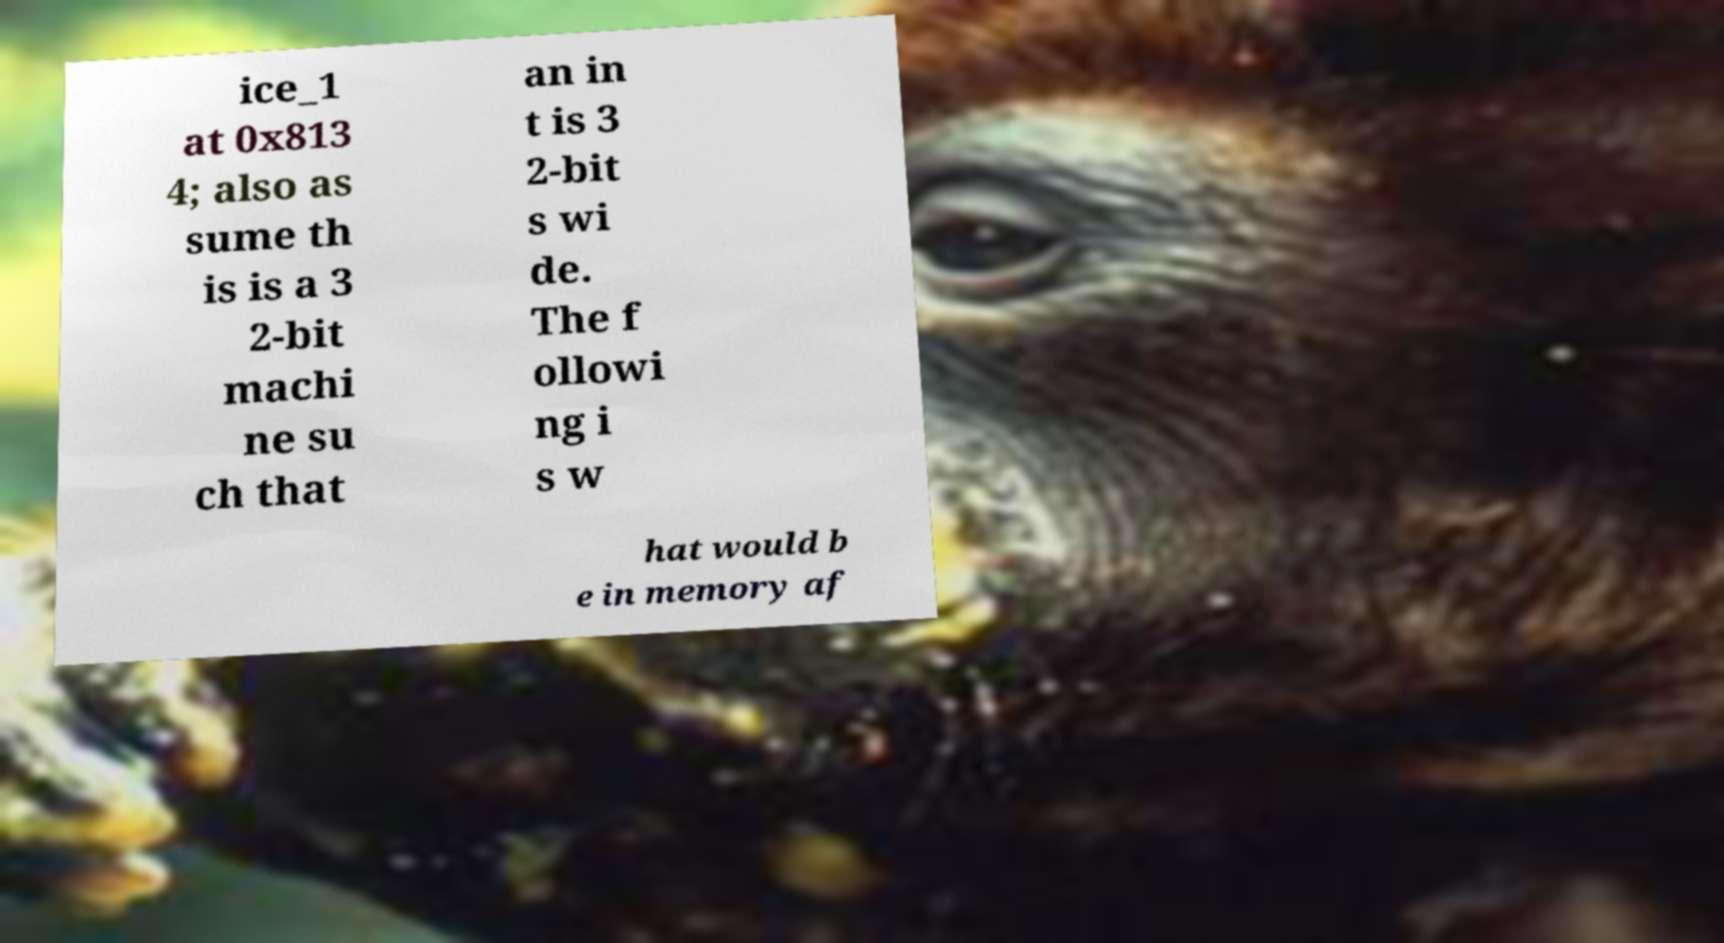What messages or text are displayed in this image? I need them in a readable, typed format. ice_1 at 0x813 4; also as sume th is is a 3 2-bit machi ne su ch that an in t is 3 2-bit s wi de. The f ollowi ng i s w hat would b e in memory af 